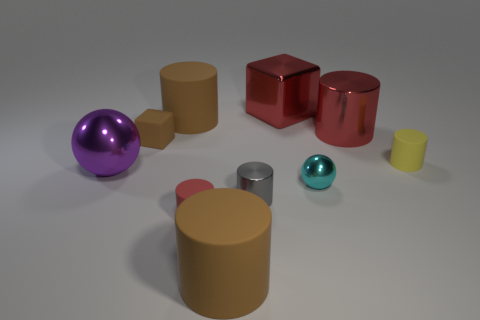Subtract 3 cylinders. How many cylinders are left? 3 Subtract all red cylinders. How many cylinders are left? 4 Subtract all tiny metallic cylinders. How many cylinders are left? 5 Subtract all cyan cylinders. Subtract all purple balls. How many cylinders are left? 6 Subtract all balls. How many objects are left? 8 Subtract 1 brown blocks. How many objects are left? 9 Subtract all big cubes. Subtract all tiny yellow cylinders. How many objects are left? 8 Add 1 large shiny spheres. How many large shiny spheres are left? 2 Add 7 red shiny cubes. How many red shiny cubes exist? 8 